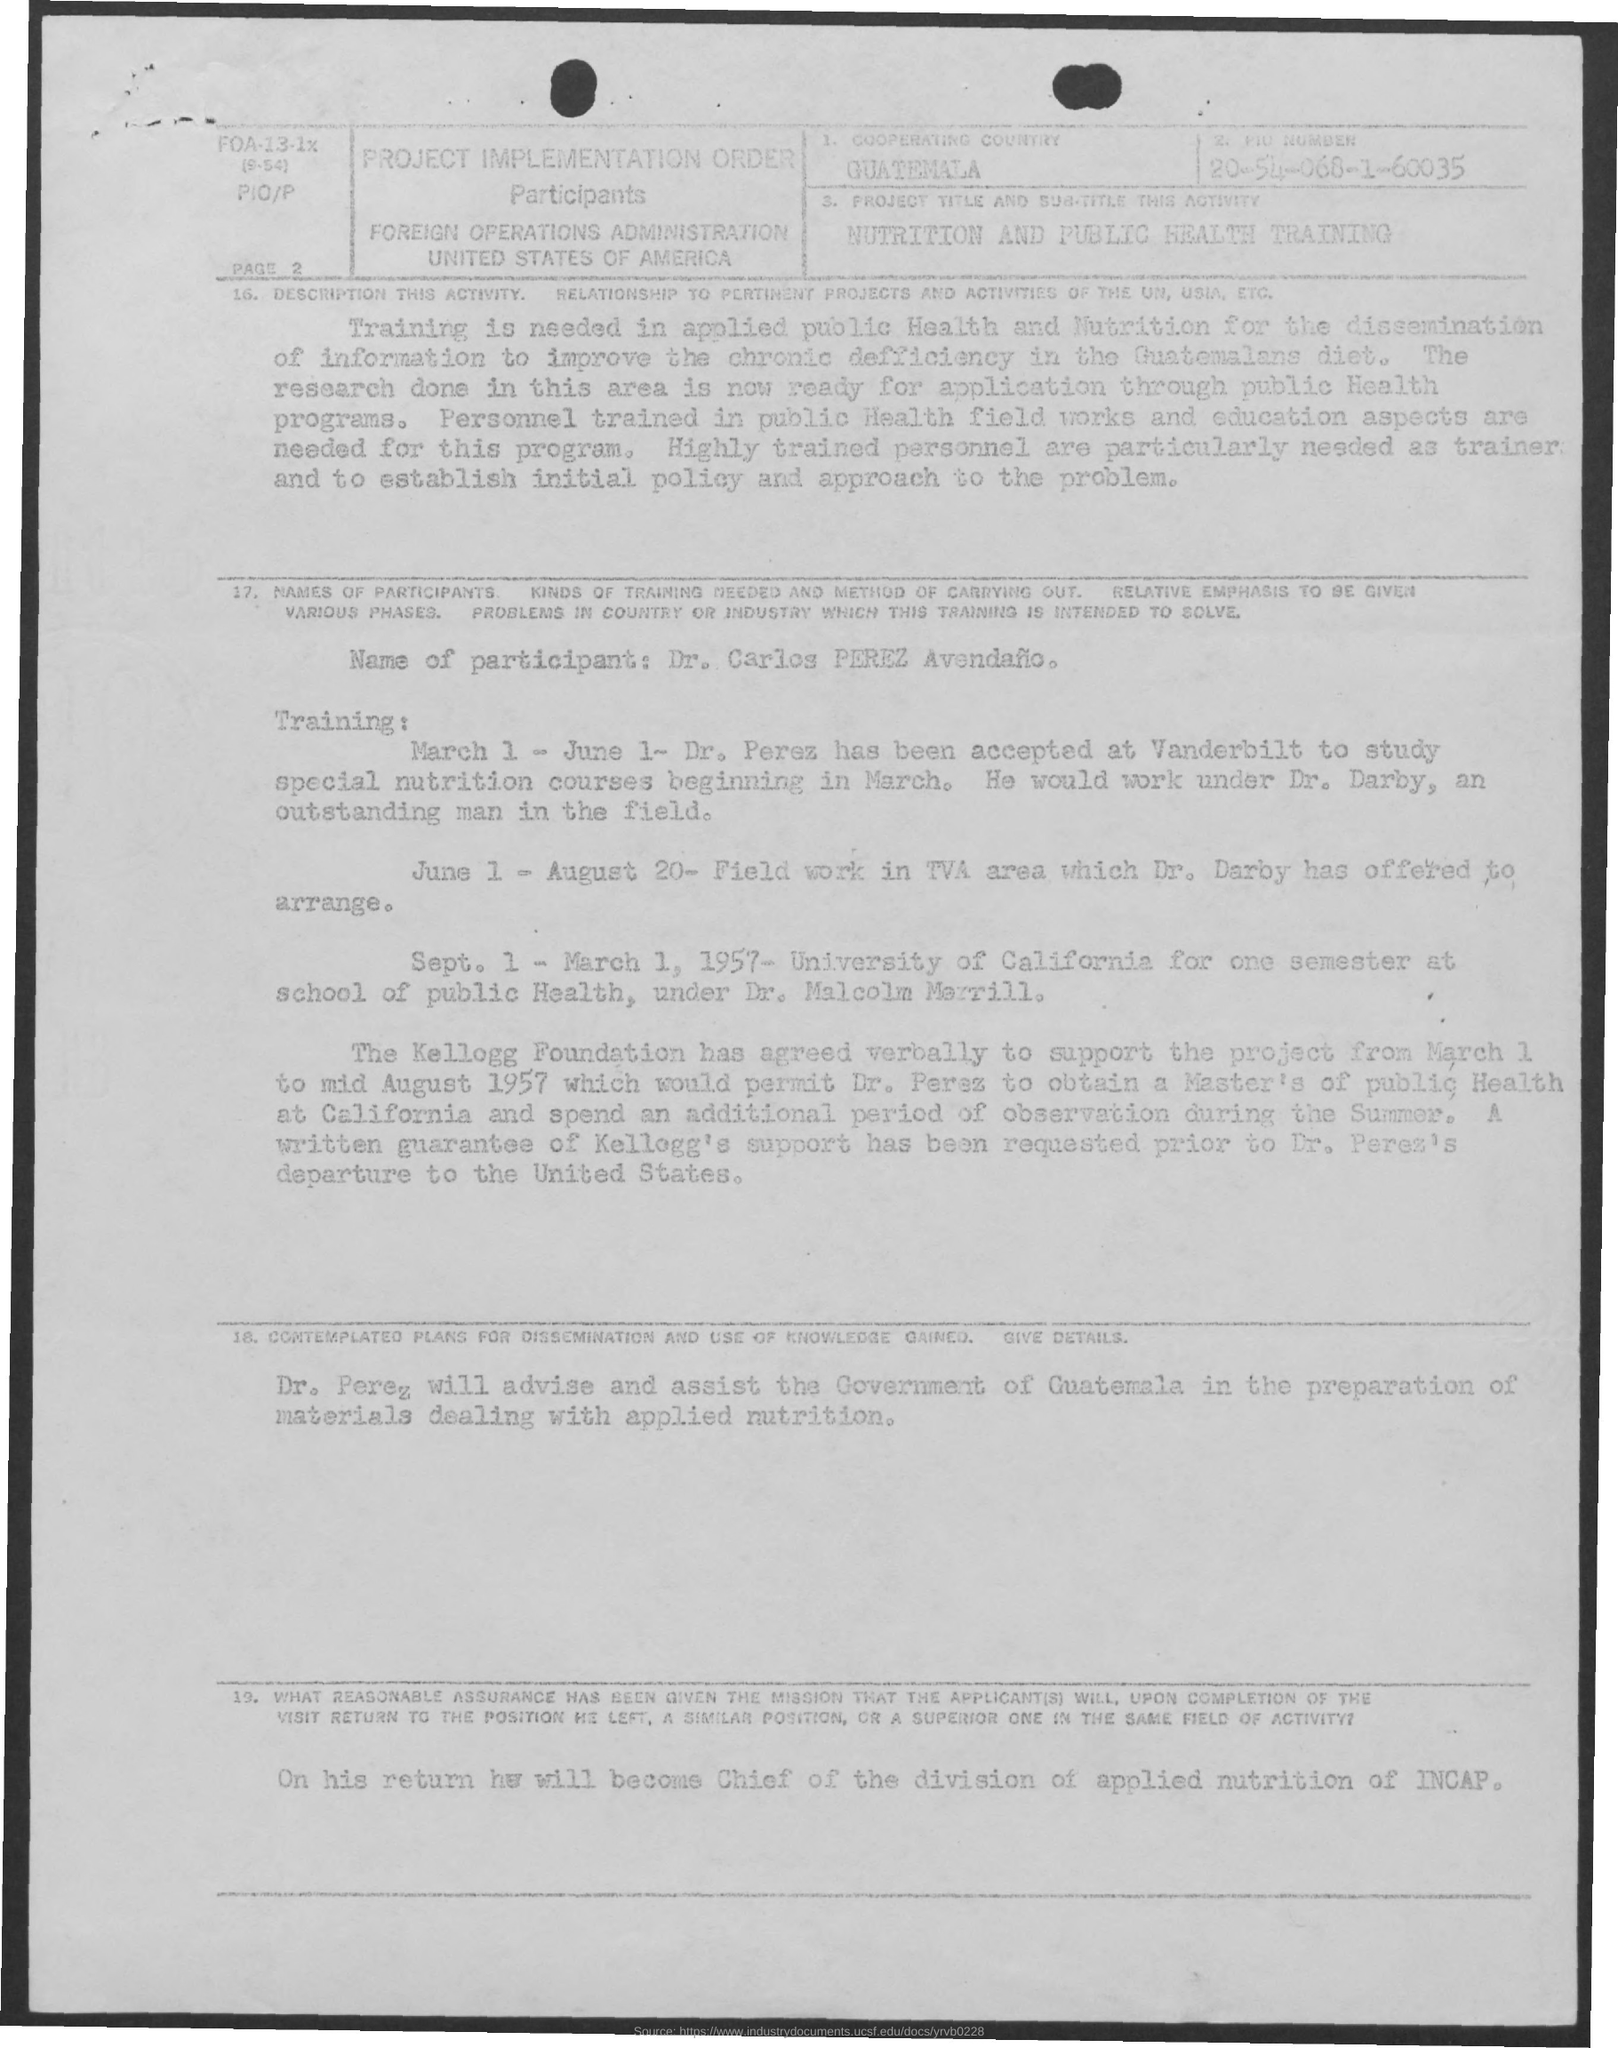Highlight a few significant elements in this photo. Guatemala is the cooperating country. 